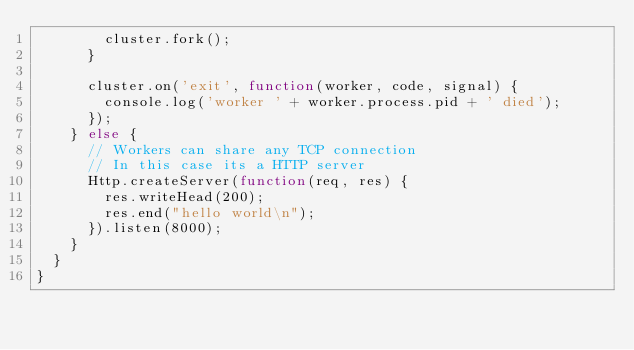<code> <loc_0><loc_0><loc_500><loc_500><_Haxe_>				cluster.fork();
			}

			cluster.on('exit', function(worker, code, signal) {
				console.log('worker ' + worker.process.pid + ' died');
			});
		} else {
			// Workers can share any TCP connection
			// In this case its a HTTP server
			Http.createServer(function(req, res) {
				res.writeHead(200);
				res.end("hello world\n");
			}).listen(8000);
		}
	}
}</code> 